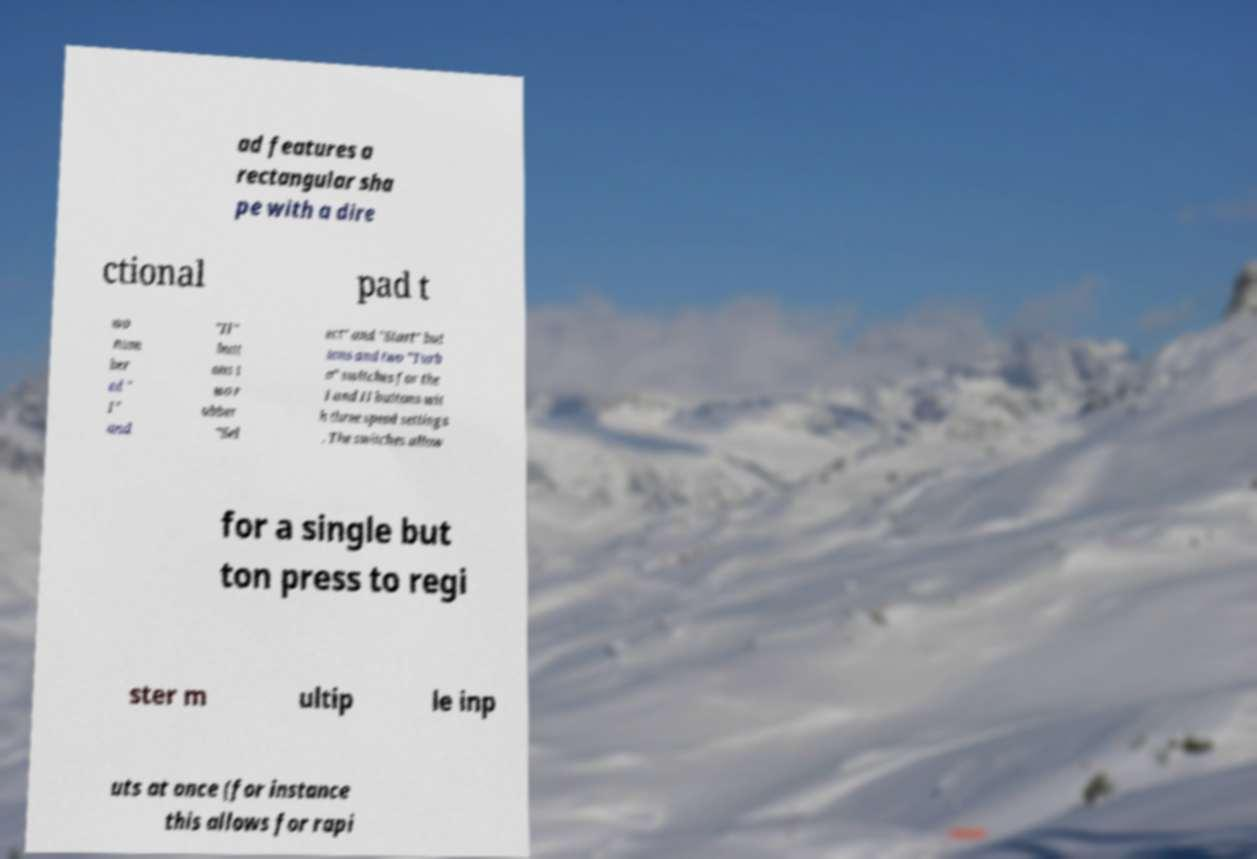Could you assist in decoding the text presented in this image and type it out clearly? ad features a rectangular sha pe with a dire ctional pad t wo num ber ed " I" and "II" butt ons t wo r ubber "Sel ect" and "Start" but tons and two "Turb o" switches for the I and II buttons wit h three speed settings . The switches allow for a single but ton press to regi ster m ultip le inp uts at once (for instance this allows for rapi 